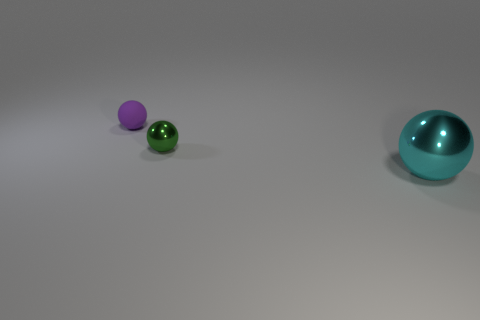Is there any other thing that is the same size as the cyan sphere?
Provide a short and direct response. No. Are there the same number of spheres behind the tiny shiny sphere and purple things?
Make the answer very short. Yes. There is a thing that is both in front of the purple object and on the left side of the big metallic sphere; what shape is it?
Offer a terse response. Sphere. Is the purple sphere the same size as the cyan metallic thing?
Keep it short and to the point. No. Is there a big cyan sphere made of the same material as the small green object?
Offer a terse response. Yes. How many objects are both left of the cyan ball and on the right side of the tiny purple sphere?
Your answer should be compact. 1. There is a tiny thing behind the tiny green sphere; what material is it?
Your response must be concise. Rubber. What number of large shiny objects have the same color as the rubber object?
Keep it short and to the point. 0. There is another green ball that is the same material as the big sphere; what size is it?
Provide a succinct answer. Small. How many objects are either brown matte cylinders or rubber balls?
Offer a very short reply. 1. 